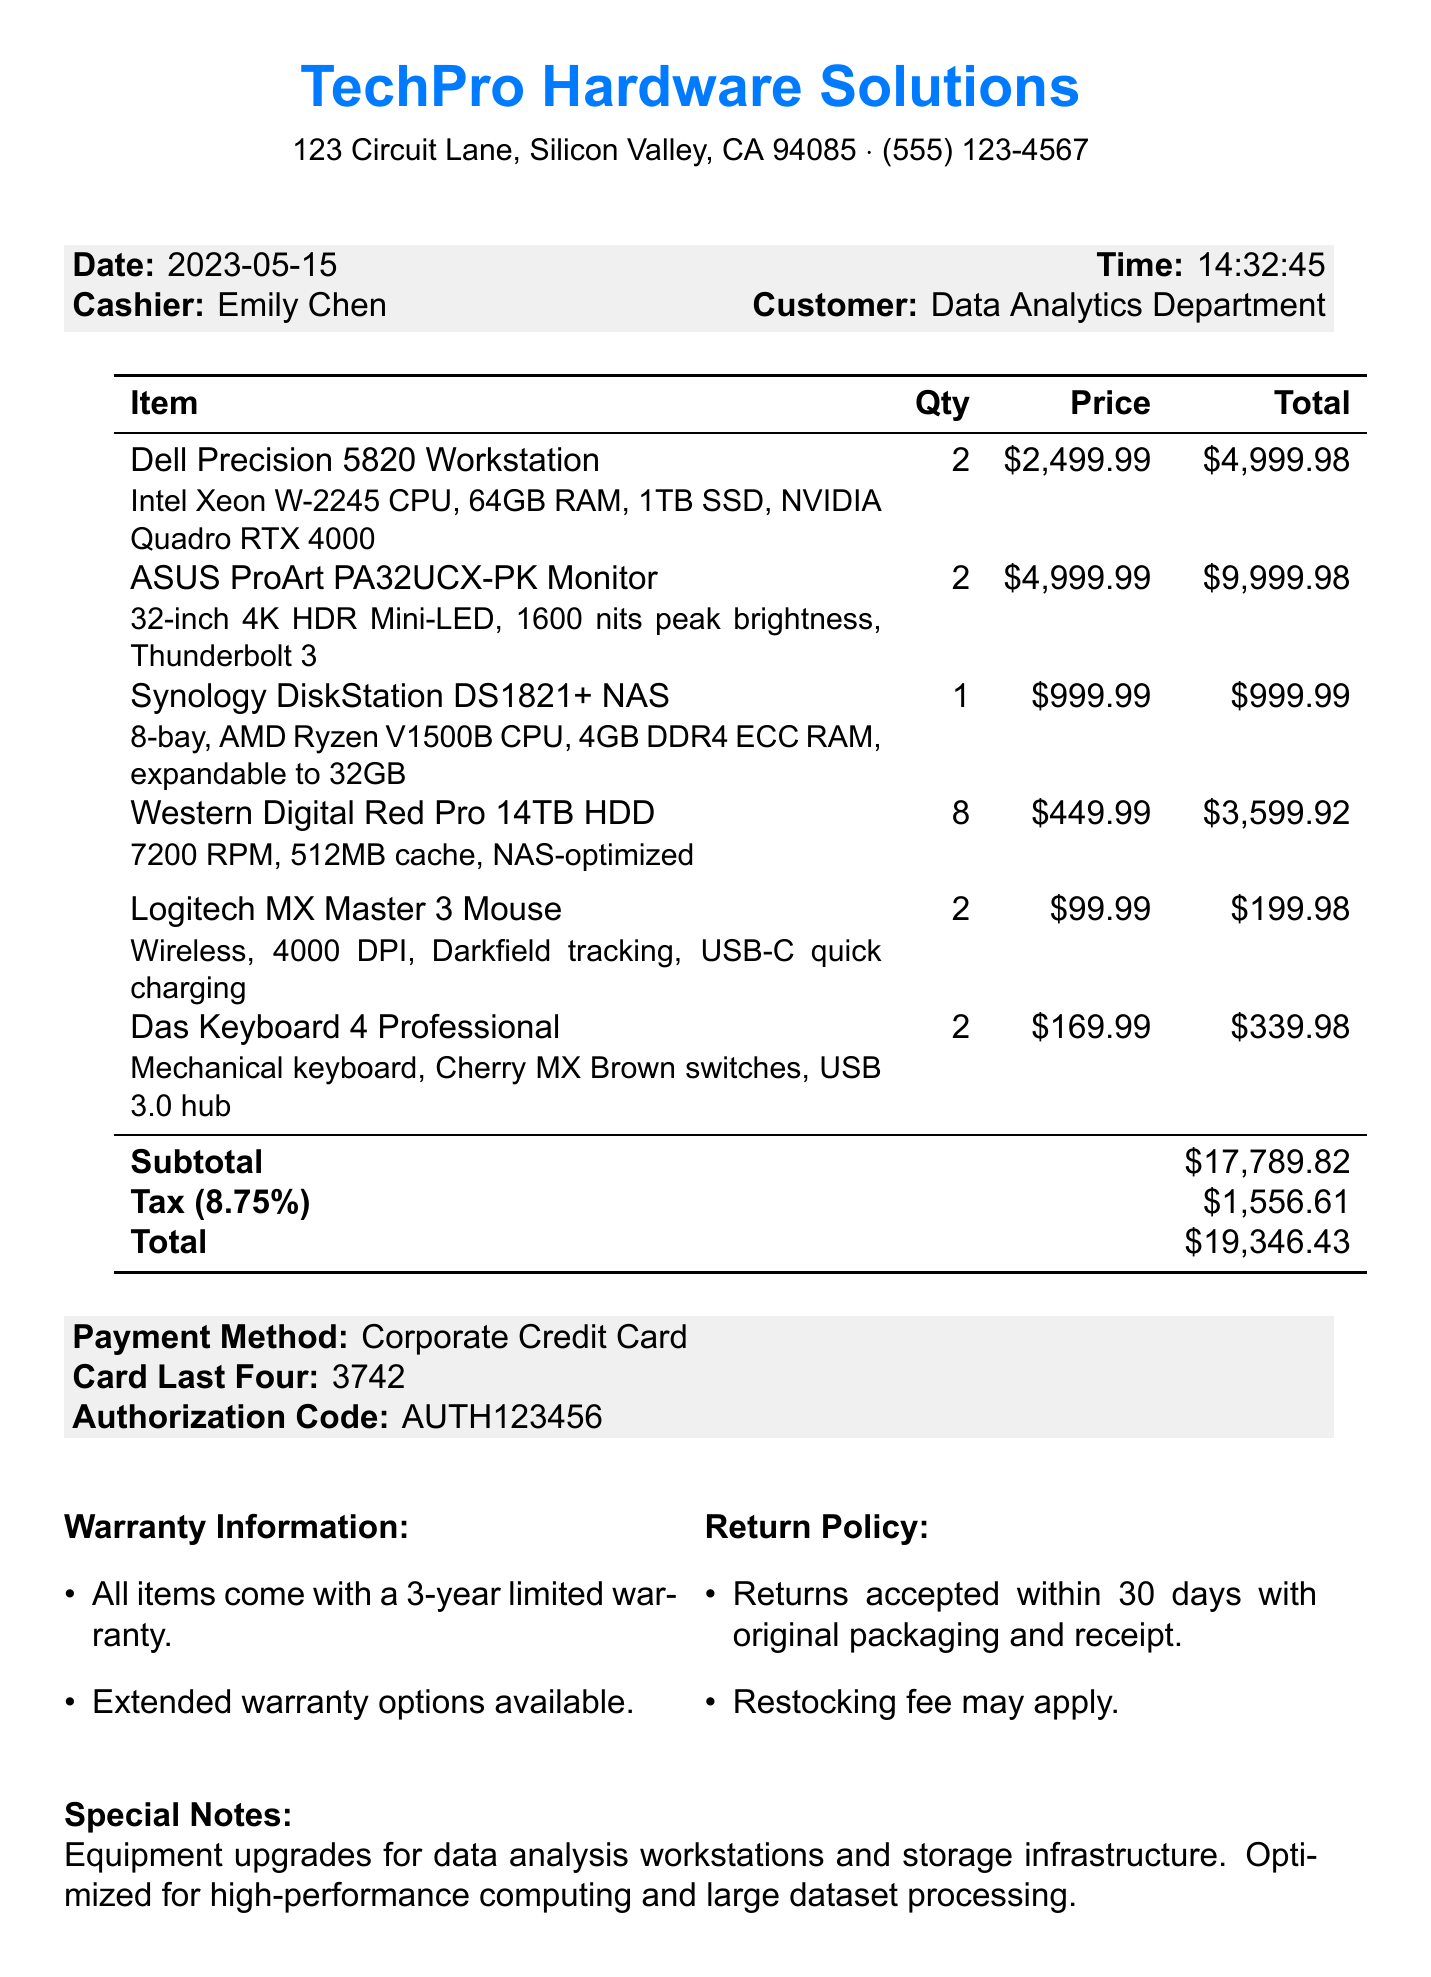What is the name of the store? The name of the store is listed at the top of the receipt.
Answer: TechPro Hardware Solutions What is the total amount spent? The total amount is calculated at the end of the receipt.
Answer: $19,346.43 Who is the cashier? The cashier's name is mentioned in the header section of the receipt.
Answer: Emily Chen How many Dell Precision 5820 Workstations were purchased? The quantity of this item is listed next to its name in the itemized list.
Answer: 2 What is the warranty period for the items? The warranty information section specifies the duration of coverage.
Answer: 3-year limited warranty What type of CPU does the Synology DiskStation DS1821+ NAS have? The specification of the NAS includes details about its CPU.
Answer: AMD Ryzen V1500B CPU What is the return policy duration? The return policy mentions the time allowed for returns in the document.
Answer: 30 days What payment method was used for this transaction? The payment method is specified in the payment section of the receipt.
Answer: Corporate Credit Card How many Western Digital Red Pro 14TB HDDs were purchased? The quantity for these HDDs is included in the itemized list.
Answer: 8 